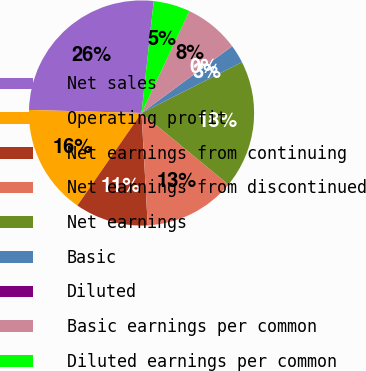Convert chart. <chart><loc_0><loc_0><loc_500><loc_500><pie_chart><fcel>Net sales<fcel>Operating profit<fcel>Net earnings from continuing<fcel>Net earnings from discontinued<fcel>Net earnings<fcel>Basic<fcel>Diluted<fcel>Basic earnings per common<fcel>Diluted earnings per common<nl><fcel>26.3%<fcel>15.79%<fcel>10.53%<fcel>13.16%<fcel>18.42%<fcel>2.64%<fcel>0.01%<fcel>7.9%<fcel>5.27%<nl></chart> 